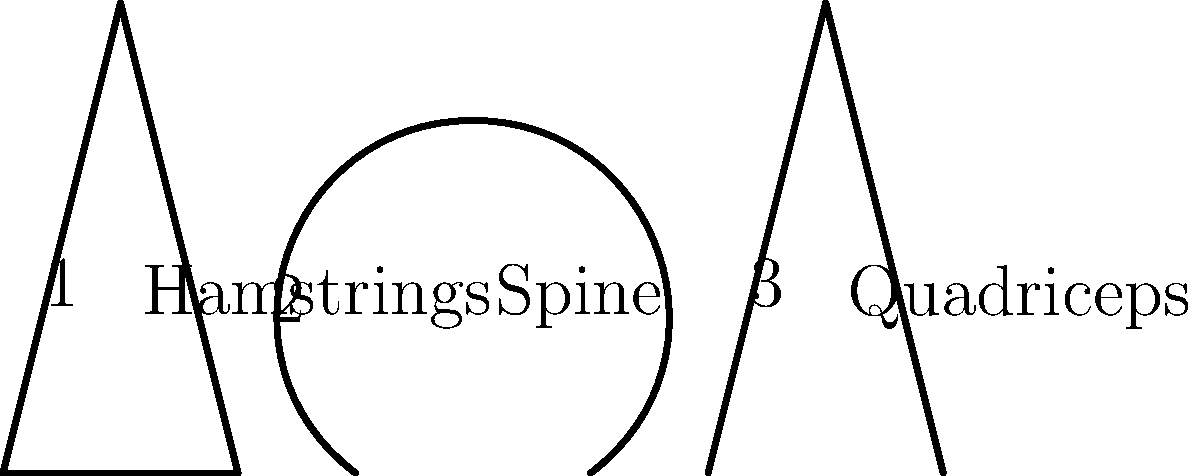In the diagram above, three yoga postures are illustrated with corresponding muscle groups affected. Which posture primarily engages the spine and is often used in Indian yoga practices for improving spinal flexibility? To answer this question, we need to analyze each posture and its associated muscle group:

1. Posture 1 (Triangle pose):
   - Shape: A triangle formed by the legs and torso
   - Labeled muscle group: Hamstrings
   - This pose primarily stretches the hamstrings and sides of the torso

2. Posture 2 (Cat-Cow pose):
   - Shape: A curved line representing the spine in flexion and extension
   - Labeled muscle group: Spine
   - This pose involves moving the spine through flexion and extension, directly engaging the spinal muscles

3. Posture 3 (Mountain pose):
   - Shape: A straight line representing the body in a standing position
   - Labeled muscle group: Quadriceps
   - This pose primarily engages the leg muscles, particularly the quadriceps

Among these three postures, only Posture 2 (Cat-Cow pose) is directly associated with the spine. This pose is widely practiced in Indian yoga traditions, such as Hatha Yoga, to improve spinal flexibility and strengthen the muscles supporting the spine.

The Cat-Cow pose (Marjaryasana-Bitilasana in Sanskrit) involves moving between two positions:
1. Cat pose: Rounding the spine (spinal flexion)
2. Cow pose: Arching the spine (spinal extension)

This alternating movement helps to:
- Increase spinal mobility
- Stretch and strengthen the muscles supporting the spine
- Improve posture and balance
- Relieve tension in the back and neck

Therefore, the posture that primarily engages the spine and is often used in Indian yoga practices for improving spinal flexibility is Posture 2, the Cat-Cow pose.
Answer: Posture 2 (Cat-Cow pose) 